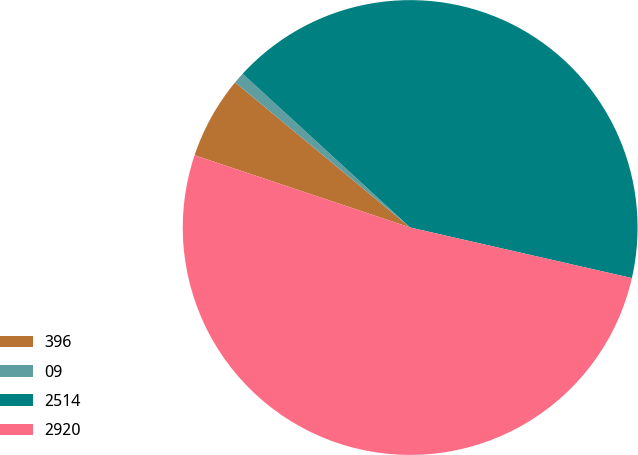<chart> <loc_0><loc_0><loc_500><loc_500><pie_chart><fcel>396<fcel>09<fcel>2514<fcel>2920<nl><fcel>5.87%<fcel>0.8%<fcel>41.75%<fcel>51.58%<nl></chart> 